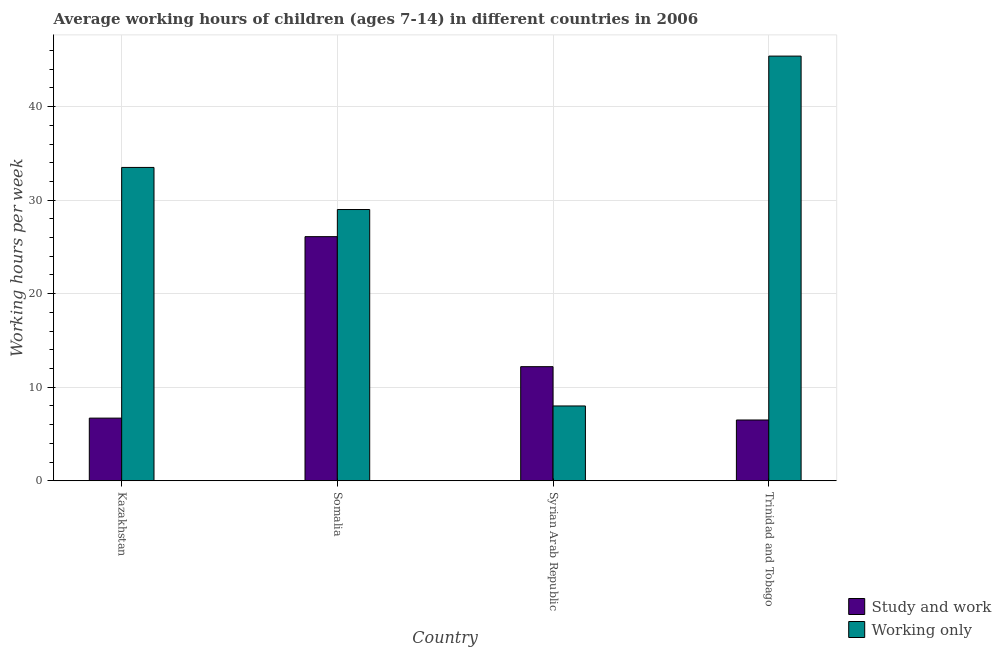How many groups of bars are there?
Your answer should be very brief. 4. Are the number of bars per tick equal to the number of legend labels?
Give a very brief answer. Yes. Are the number of bars on each tick of the X-axis equal?
Your answer should be compact. Yes. What is the label of the 1st group of bars from the left?
Your answer should be very brief. Kazakhstan. What is the average working hour of children involved in only work in Trinidad and Tobago?
Provide a short and direct response. 45.4. Across all countries, what is the maximum average working hour of children involved in study and work?
Ensure brevity in your answer.  26.1. In which country was the average working hour of children involved in only work maximum?
Offer a very short reply. Trinidad and Tobago. In which country was the average working hour of children involved in study and work minimum?
Provide a succinct answer. Trinidad and Tobago. What is the total average working hour of children involved in only work in the graph?
Offer a terse response. 115.9. What is the difference between the average working hour of children involved in study and work in Kazakhstan and that in Somalia?
Provide a succinct answer. -19.4. What is the difference between the average working hour of children involved in study and work in Somalia and the average working hour of children involved in only work in Trinidad and Tobago?
Provide a short and direct response. -19.3. What is the average average working hour of children involved in study and work per country?
Offer a terse response. 12.88. What is the difference between the average working hour of children involved in study and work and average working hour of children involved in only work in Somalia?
Keep it short and to the point. -2.9. In how many countries, is the average working hour of children involved in only work greater than 32 hours?
Your answer should be compact. 2. What is the ratio of the average working hour of children involved in study and work in Syrian Arab Republic to that in Trinidad and Tobago?
Your answer should be compact. 1.88. Is the difference between the average working hour of children involved in only work in Kazakhstan and Syrian Arab Republic greater than the difference between the average working hour of children involved in study and work in Kazakhstan and Syrian Arab Republic?
Provide a short and direct response. Yes. What is the difference between the highest and the second highest average working hour of children involved in only work?
Offer a very short reply. 11.9. What is the difference between the highest and the lowest average working hour of children involved in study and work?
Provide a short and direct response. 19.6. What does the 2nd bar from the left in Trinidad and Tobago represents?
Your response must be concise. Working only. What does the 1st bar from the right in Kazakhstan represents?
Your response must be concise. Working only. Are all the bars in the graph horizontal?
Make the answer very short. No. What is the difference between two consecutive major ticks on the Y-axis?
Give a very brief answer. 10. Does the graph contain any zero values?
Your response must be concise. No. How many legend labels are there?
Give a very brief answer. 2. What is the title of the graph?
Offer a terse response. Average working hours of children (ages 7-14) in different countries in 2006. What is the label or title of the X-axis?
Ensure brevity in your answer.  Country. What is the label or title of the Y-axis?
Your answer should be compact. Working hours per week. What is the Working hours per week of Study and work in Kazakhstan?
Your response must be concise. 6.7. What is the Working hours per week of Working only in Kazakhstan?
Your response must be concise. 33.5. What is the Working hours per week of Study and work in Somalia?
Give a very brief answer. 26.1. What is the Working hours per week of Working only in Somalia?
Provide a succinct answer. 29. What is the Working hours per week in Working only in Syrian Arab Republic?
Offer a very short reply. 8. What is the Working hours per week of Working only in Trinidad and Tobago?
Make the answer very short. 45.4. Across all countries, what is the maximum Working hours per week in Study and work?
Your response must be concise. 26.1. Across all countries, what is the maximum Working hours per week of Working only?
Your answer should be very brief. 45.4. Across all countries, what is the minimum Working hours per week of Study and work?
Provide a short and direct response. 6.5. What is the total Working hours per week in Study and work in the graph?
Offer a terse response. 51.5. What is the total Working hours per week of Working only in the graph?
Make the answer very short. 115.9. What is the difference between the Working hours per week of Study and work in Kazakhstan and that in Somalia?
Make the answer very short. -19.4. What is the difference between the Working hours per week of Working only in Kazakhstan and that in Somalia?
Make the answer very short. 4.5. What is the difference between the Working hours per week of Study and work in Kazakhstan and that in Syrian Arab Republic?
Your answer should be compact. -5.5. What is the difference between the Working hours per week of Study and work in Kazakhstan and that in Trinidad and Tobago?
Your answer should be compact. 0.2. What is the difference between the Working hours per week in Working only in Kazakhstan and that in Trinidad and Tobago?
Provide a short and direct response. -11.9. What is the difference between the Working hours per week in Study and work in Somalia and that in Trinidad and Tobago?
Keep it short and to the point. 19.6. What is the difference between the Working hours per week of Working only in Somalia and that in Trinidad and Tobago?
Ensure brevity in your answer.  -16.4. What is the difference between the Working hours per week of Working only in Syrian Arab Republic and that in Trinidad and Tobago?
Ensure brevity in your answer.  -37.4. What is the difference between the Working hours per week in Study and work in Kazakhstan and the Working hours per week in Working only in Somalia?
Make the answer very short. -22.3. What is the difference between the Working hours per week in Study and work in Kazakhstan and the Working hours per week in Working only in Syrian Arab Republic?
Keep it short and to the point. -1.3. What is the difference between the Working hours per week in Study and work in Kazakhstan and the Working hours per week in Working only in Trinidad and Tobago?
Provide a succinct answer. -38.7. What is the difference between the Working hours per week in Study and work in Somalia and the Working hours per week in Working only in Syrian Arab Republic?
Your answer should be compact. 18.1. What is the difference between the Working hours per week of Study and work in Somalia and the Working hours per week of Working only in Trinidad and Tobago?
Keep it short and to the point. -19.3. What is the difference between the Working hours per week of Study and work in Syrian Arab Republic and the Working hours per week of Working only in Trinidad and Tobago?
Your answer should be compact. -33.2. What is the average Working hours per week in Study and work per country?
Offer a very short reply. 12.88. What is the average Working hours per week of Working only per country?
Make the answer very short. 28.98. What is the difference between the Working hours per week of Study and work and Working hours per week of Working only in Kazakhstan?
Ensure brevity in your answer.  -26.8. What is the difference between the Working hours per week of Study and work and Working hours per week of Working only in Syrian Arab Republic?
Make the answer very short. 4.2. What is the difference between the Working hours per week in Study and work and Working hours per week in Working only in Trinidad and Tobago?
Your response must be concise. -38.9. What is the ratio of the Working hours per week of Study and work in Kazakhstan to that in Somalia?
Your answer should be compact. 0.26. What is the ratio of the Working hours per week of Working only in Kazakhstan to that in Somalia?
Ensure brevity in your answer.  1.16. What is the ratio of the Working hours per week of Study and work in Kazakhstan to that in Syrian Arab Republic?
Give a very brief answer. 0.55. What is the ratio of the Working hours per week in Working only in Kazakhstan to that in Syrian Arab Republic?
Offer a very short reply. 4.19. What is the ratio of the Working hours per week of Study and work in Kazakhstan to that in Trinidad and Tobago?
Offer a terse response. 1.03. What is the ratio of the Working hours per week in Working only in Kazakhstan to that in Trinidad and Tobago?
Provide a succinct answer. 0.74. What is the ratio of the Working hours per week of Study and work in Somalia to that in Syrian Arab Republic?
Your response must be concise. 2.14. What is the ratio of the Working hours per week of Working only in Somalia to that in Syrian Arab Republic?
Your response must be concise. 3.62. What is the ratio of the Working hours per week in Study and work in Somalia to that in Trinidad and Tobago?
Your answer should be very brief. 4.02. What is the ratio of the Working hours per week of Working only in Somalia to that in Trinidad and Tobago?
Your answer should be compact. 0.64. What is the ratio of the Working hours per week of Study and work in Syrian Arab Republic to that in Trinidad and Tobago?
Ensure brevity in your answer.  1.88. What is the ratio of the Working hours per week in Working only in Syrian Arab Republic to that in Trinidad and Tobago?
Make the answer very short. 0.18. What is the difference between the highest and the second highest Working hours per week in Study and work?
Offer a very short reply. 13.9. What is the difference between the highest and the lowest Working hours per week in Study and work?
Give a very brief answer. 19.6. What is the difference between the highest and the lowest Working hours per week in Working only?
Your answer should be compact. 37.4. 